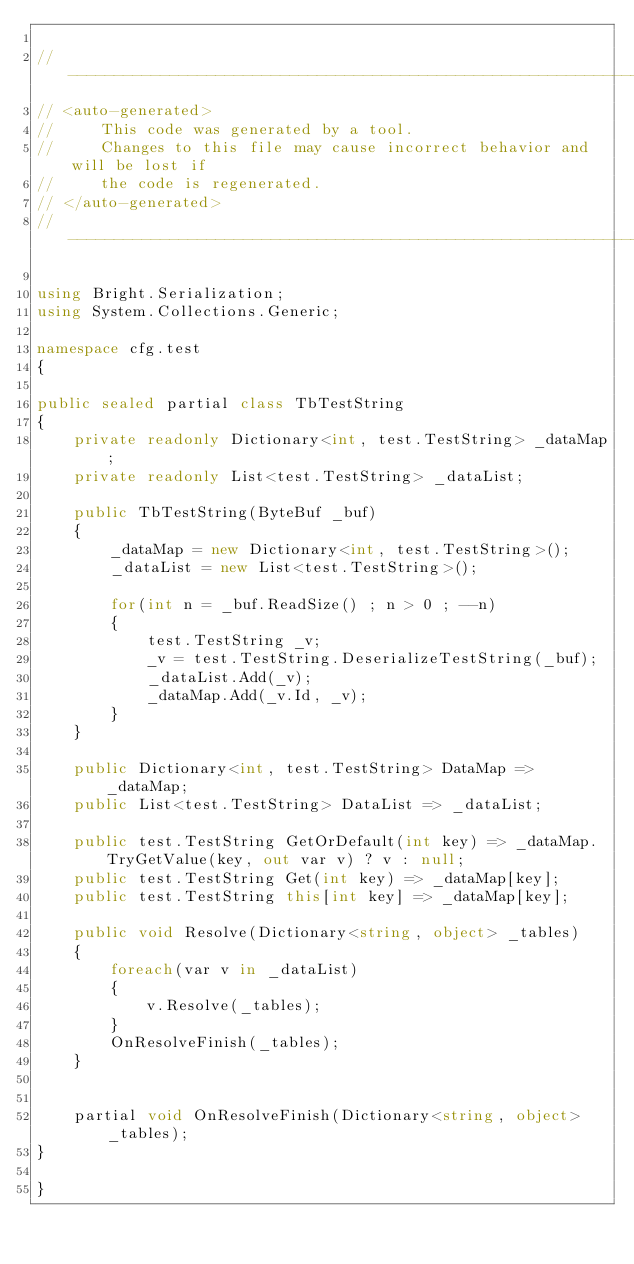Convert code to text. <code><loc_0><loc_0><loc_500><loc_500><_C#_>
//------------------------------------------------------------------------------
// <auto-generated>
//     This code was generated by a tool.
//     Changes to this file may cause incorrect behavior and will be lost if
//     the code is regenerated.
// </auto-generated>
//------------------------------------------------------------------------------

using Bright.Serialization;
using System.Collections.Generic;

namespace cfg.test
{
   
public sealed partial class TbTestString
{
    private readonly Dictionary<int, test.TestString> _dataMap;
    private readonly List<test.TestString> _dataList;
    
    public TbTestString(ByteBuf _buf)
    {
        _dataMap = new Dictionary<int, test.TestString>();
        _dataList = new List<test.TestString>();
        
        for(int n = _buf.ReadSize() ; n > 0 ; --n)
        {
            test.TestString _v;
            _v = test.TestString.DeserializeTestString(_buf);
            _dataList.Add(_v);
            _dataMap.Add(_v.Id, _v);
        }
    }

    public Dictionary<int, test.TestString> DataMap => _dataMap;
    public List<test.TestString> DataList => _dataList;

    public test.TestString GetOrDefault(int key) => _dataMap.TryGetValue(key, out var v) ? v : null;
    public test.TestString Get(int key) => _dataMap[key];
    public test.TestString this[int key] => _dataMap[key];

    public void Resolve(Dictionary<string, object> _tables)
    {
        foreach(var v in _dataList)
        {
            v.Resolve(_tables);
        }
        OnResolveFinish(_tables);
    }


    partial void OnResolveFinish(Dictionary<string, object> _tables);
}

}
</code> 